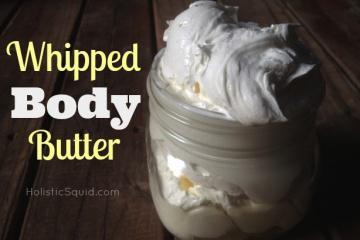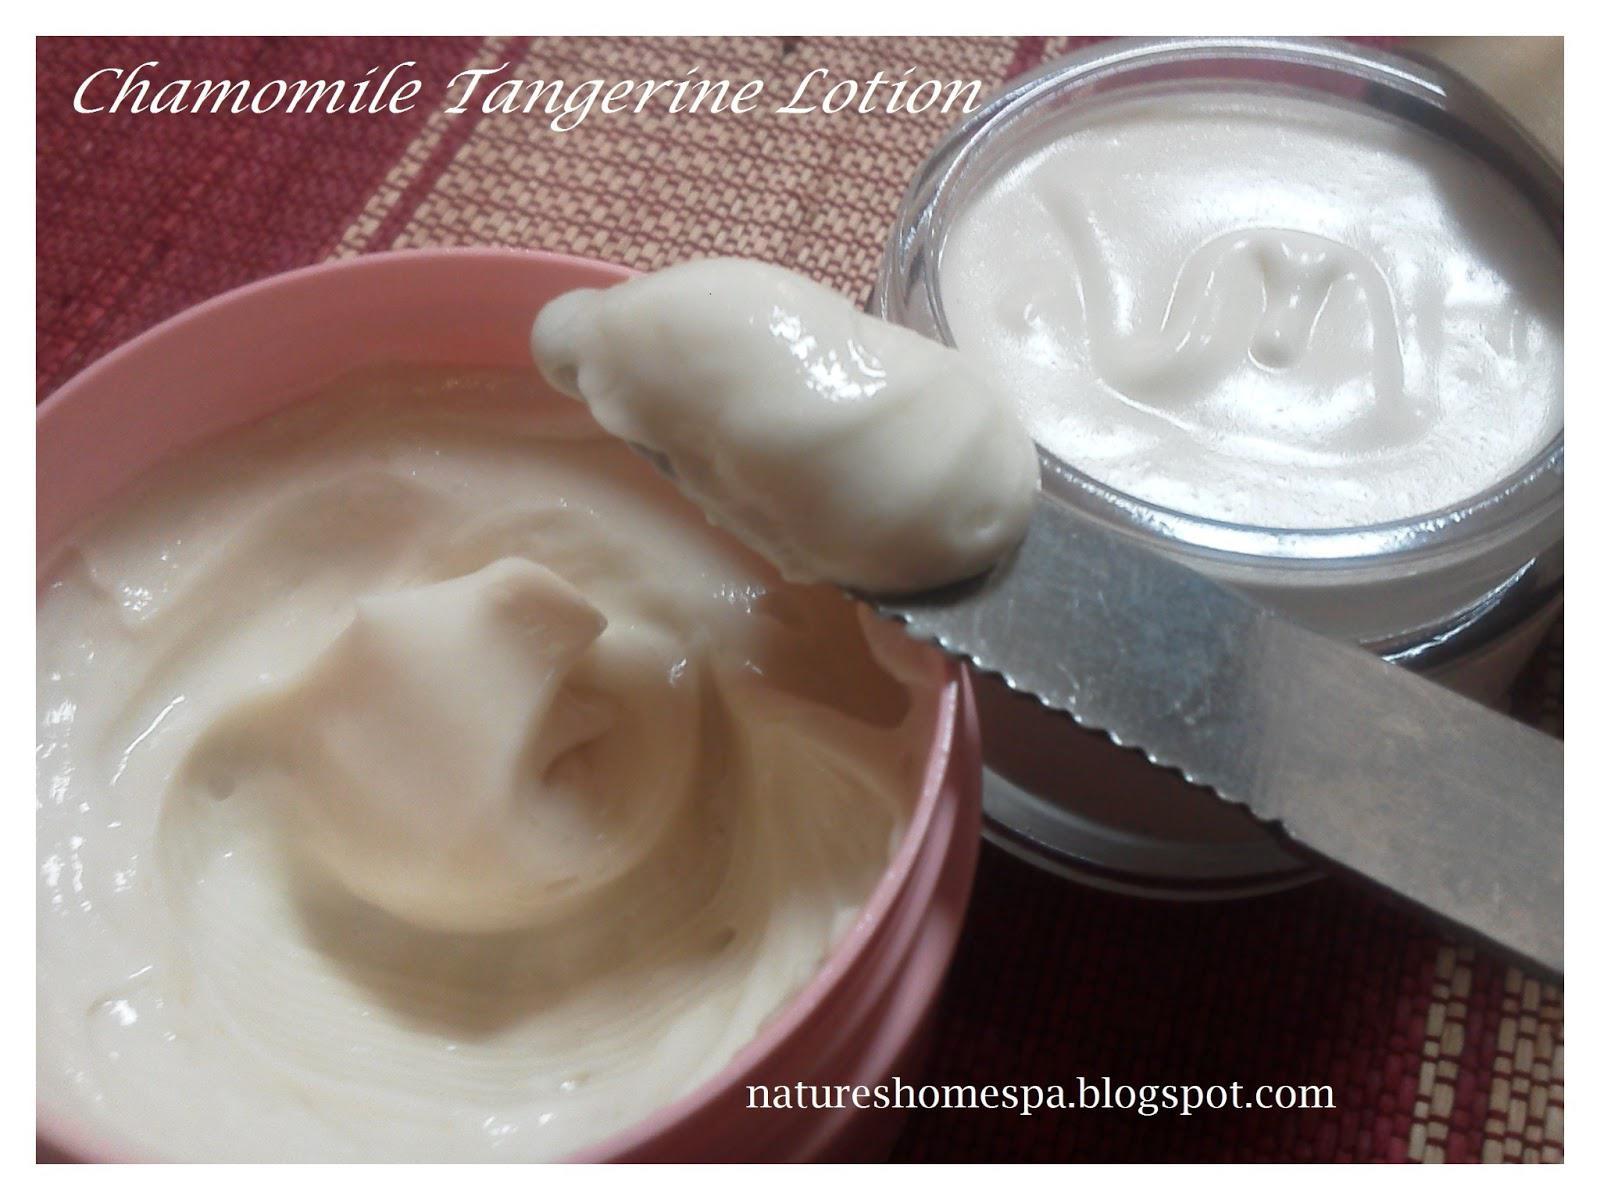The first image is the image on the left, the second image is the image on the right. Examine the images to the left and right. Is the description "There is a white lotion in one image and a yellow lotion in the other." accurate? Answer yes or no. No. The first image is the image on the left, the second image is the image on the right. Considering the images on both sides, is "An image shows an open jar filled with white creamy concoction, sitting on a wood-grain surface." valid? Answer yes or no. Yes. 